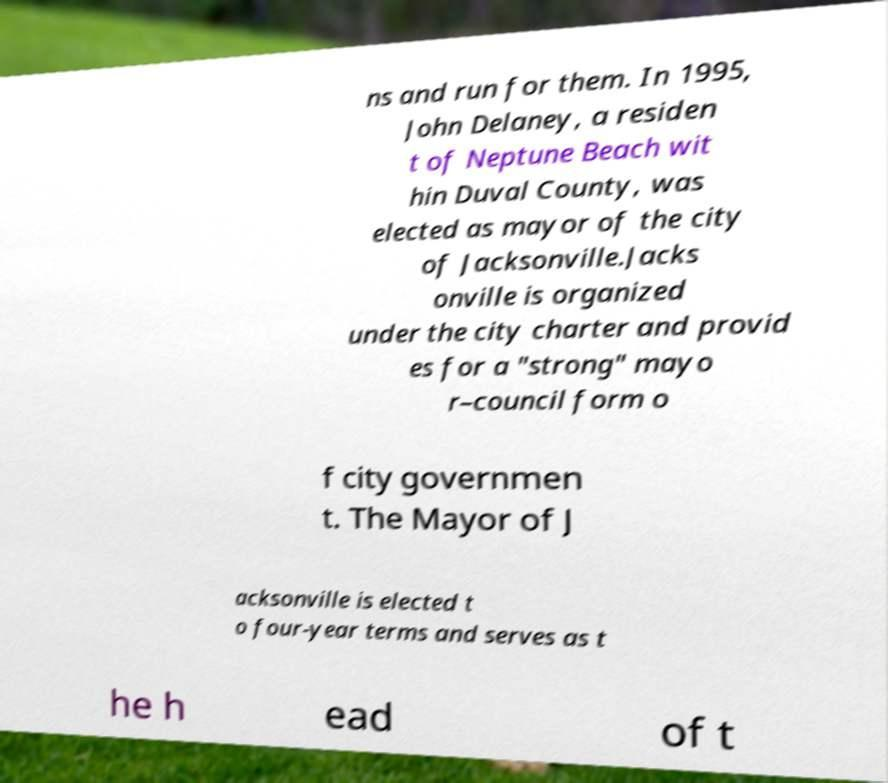Can you accurately transcribe the text from the provided image for me? ns and run for them. In 1995, John Delaney, a residen t of Neptune Beach wit hin Duval County, was elected as mayor of the city of Jacksonville.Jacks onville is organized under the city charter and provid es for a "strong" mayo r–council form o f city governmen t. The Mayor of J acksonville is elected t o four-year terms and serves as t he h ead of t 